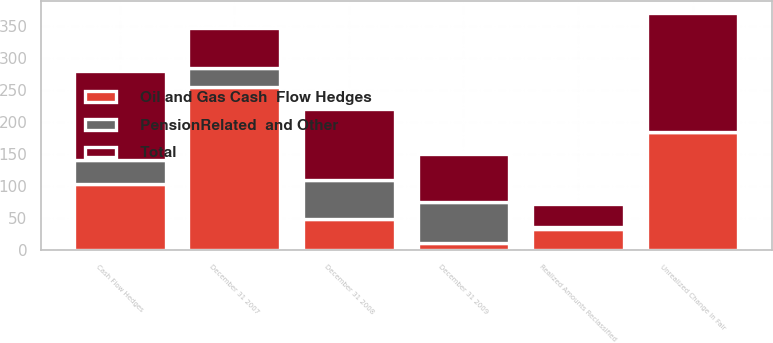Convert chart to OTSL. <chart><loc_0><loc_0><loc_500><loc_500><stacked_bar_chart><ecel><fcel>Cash Flow Hedges<fcel>Realized Amounts Reclassified<fcel>Unrealized Change in Fair<fcel>December 31 2007<fcel>December 31 2008<fcel>December 31 2009<nl><fcel>Oil and Gas Cash  Flow Hedges<fcel>104<fcel>33<fcel>184<fcel>255<fcel>48<fcel>12<nl><fcel>PensionRelated  and Other<fcel>36<fcel>3<fcel>1<fcel>29<fcel>62<fcel>63<nl><fcel>Total<fcel>140<fcel>36<fcel>185<fcel>62<fcel>110<fcel>75<nl></chart> 